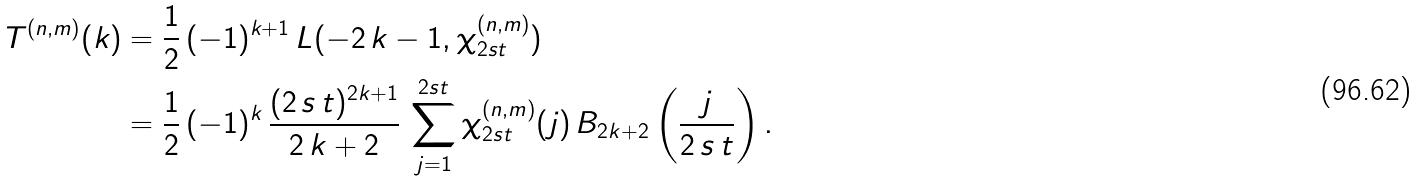<formula> <loc_0><loc_0><loc_500><loc_500>T ^ { ( n , m ) } ( k ) & = \frac { 1 } { 2 } \, ( - 1 ) ^ { k + 1 } \, L ( - 2 \, k - 1 , \chi _ { 2 s t } ^ { ( n , m ) } ) \\ & = \frac { 1 } { 2 } \, ( - 1 ) ^ { k } \, \frac { ( 2 \, s \, t ) ^ { 2 k + 1 } } { 2 \, k + 2 } \, \sum _ { j = 1 } ^ { 2 s t } \chi _ { 2 s t } ^ { ( n , m ) } ( j ) \, B _ { 2 k + 2 } \left ( \frac { j } { 2 \, s \, t } \right ) .</formula> 